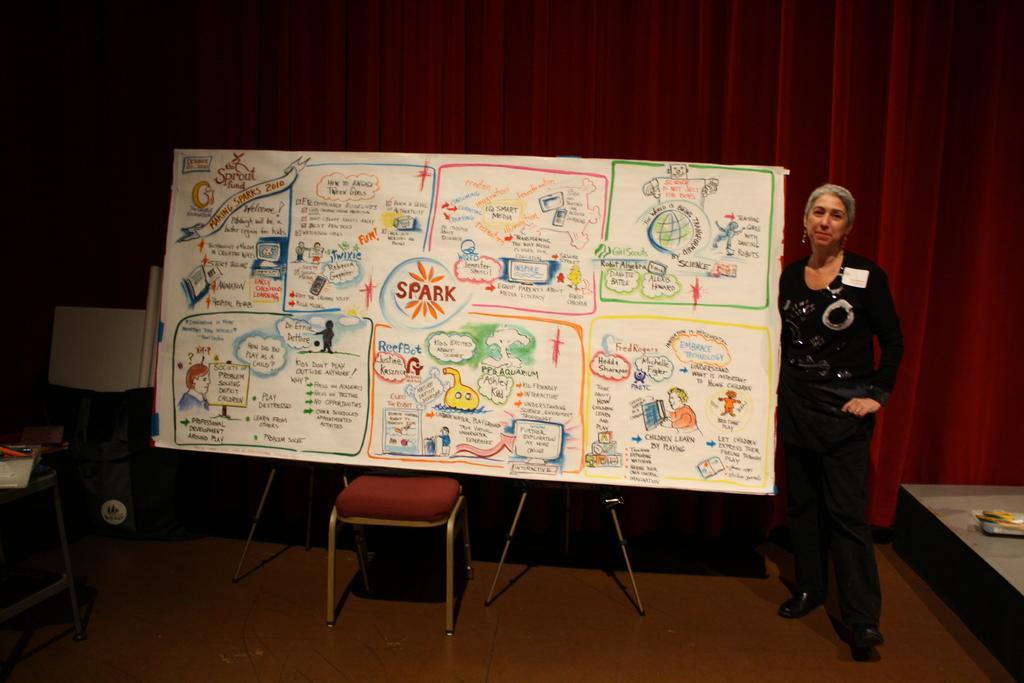Please provide a concise description of this image. In this image, we can see a board on the chair. There is a stool in the bottom left of the image. There is a stage in the bottom right of the image. There is a person on the right side of the image standing and wearing clothes. In the background of the image, we can see curtains. 